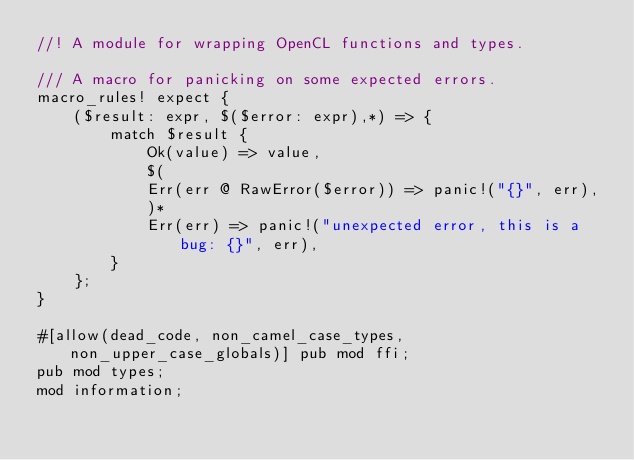Convert code to text. <code><loc_0><loc_0><loc_500><loc_500><_Rust_>//! A module for wrapping OpenCL functions and types.

/// A macro for panicking on some expected errors.
macro_rules! expect {
    ($result: expr, $($error: expr),*) => {
        match $result {
            Ok(value) => value,
            $(
            Err(err @ RawError($error)) => panic!("{}", err),
            )*
            Err(err) => panic!("unexpected error, this is a bug: {}", err),
        }
    };
}

#[allow(dead_code, non_camel_case_types, non_upper_case_globals)] pub mod ffi;
pub mod types;
mod information;
</code> 